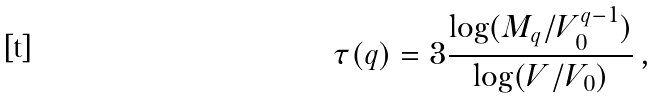<formula> <loc_0><loc_0><loc_500><loc_500>\tau ( q ) = 3 \frac { \log ( M _ { q } / V _ { 0 } ^ { q - 1 } ) } { \log ( V / V _ { 0 } ) } \, ,</formula> 